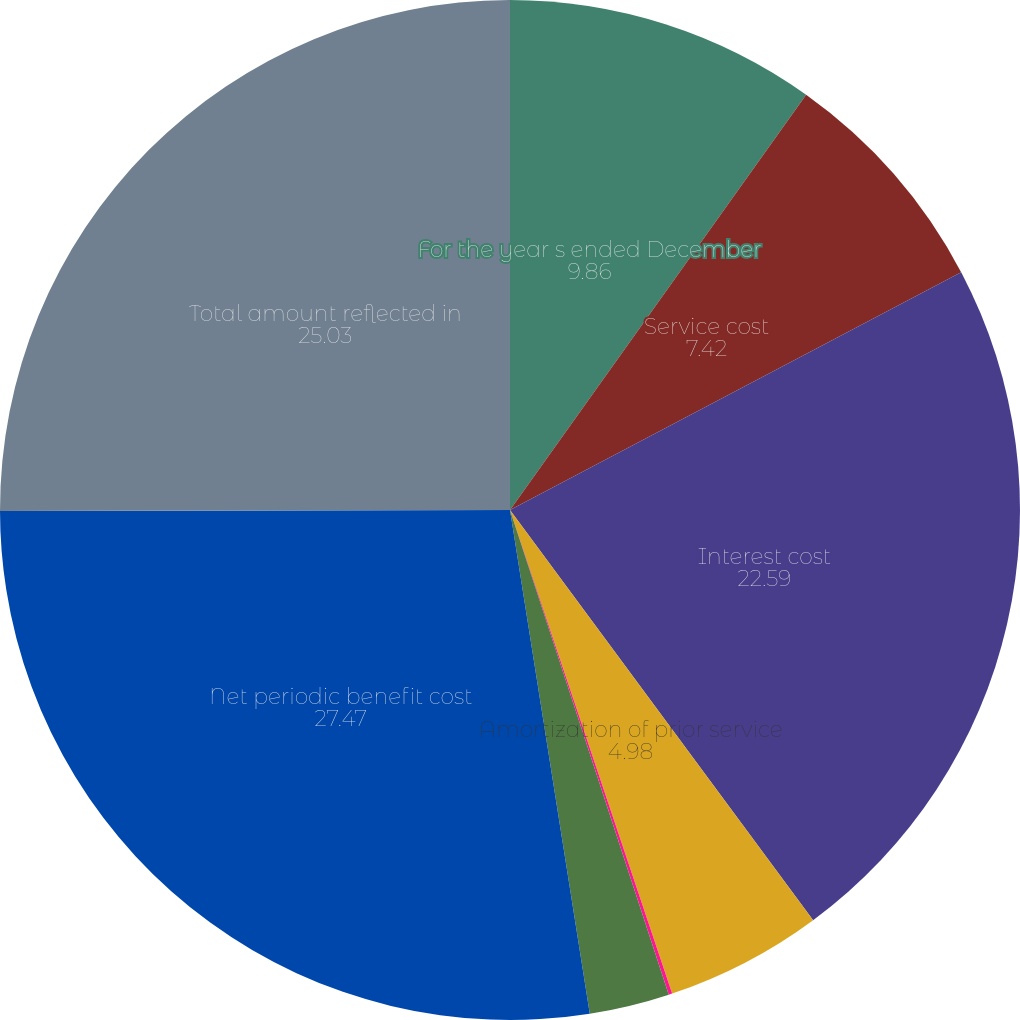Convert chart. <chart><loc_0><loc_0><loc_500><loc_500><pie_chart><fcel>For the year s ended December<fcel>Service cost<fcel>Interest cost<fcel>Amortization of prior service<fcel>Amortization of net loss<fcel>Administrative expenses<fcel>Net periodic benefit cost<fcel>Total amount reflected in<nl><fcel>9.86%<fcel>7.42%<fcel>22.59%<fcel>4.98%<fcel>0.11%<fcel>2.54%<fcel>27.47%<fcel>25.03%<nl></chart> 